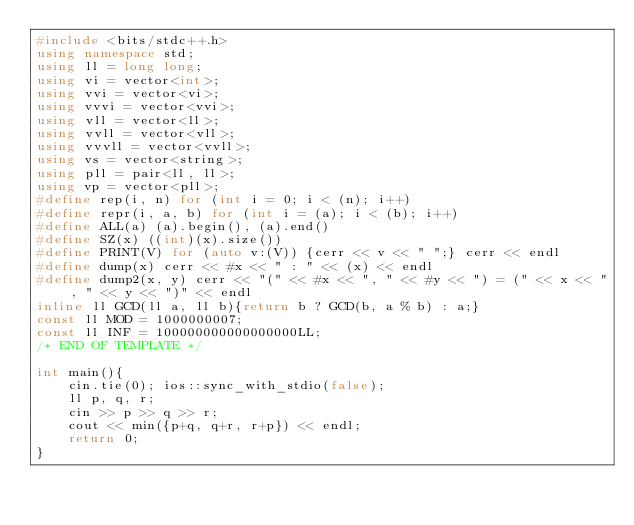Convert code to text. <code><loc_0><loc_0><loc_500><loc_500><_C++_>#include <bits/stdc++.h>
using namespace std;
using ll = long long;
using vi = vector<int>;
using vvi = vector<vi>;
using vvvi = vector<vvi>;
using vll = vector<ll>;
using vvll = vector<vll>;
using vvvll = vector<vvll>;
using vs = vector<string>;
using pll = pair<ll, ll>;
using vp = vector<pll>;
#define rep(i, n) for (int i = 0; i < (n); i++)
#define repr(i, a, b) for (int i = (a); i < (b); i++)
#define ALL(a) (a).begin(), (a).end()
#define SZ(x) ((int)(x).size())
#define PRINT(V) for (auto v:(V)) {cerr << v << " ";} cerr << endl
#define dump(x) cerr << #x << " : " << (x) << endl
#define dump2(x, y) cerr << "(" << #x << ", " << #y << ") = (" << x << ", " << y << ")" << endl
inline ll GCD(ll a, ll b){return b ? GCD(b, a % b) : a;}
const ll MOD = 1000000007;
const ll INF = 100000000000000000LL;
/* END OF TEMPLATE */

int main(){
    cin.tie(0); ios::sync_with_stdio(false);
    ll p, q, r;
    cin >> p >> q >> r;
    cout << min({p+q, q+r, r+p}) << endl;
    return 0;
}</code> 